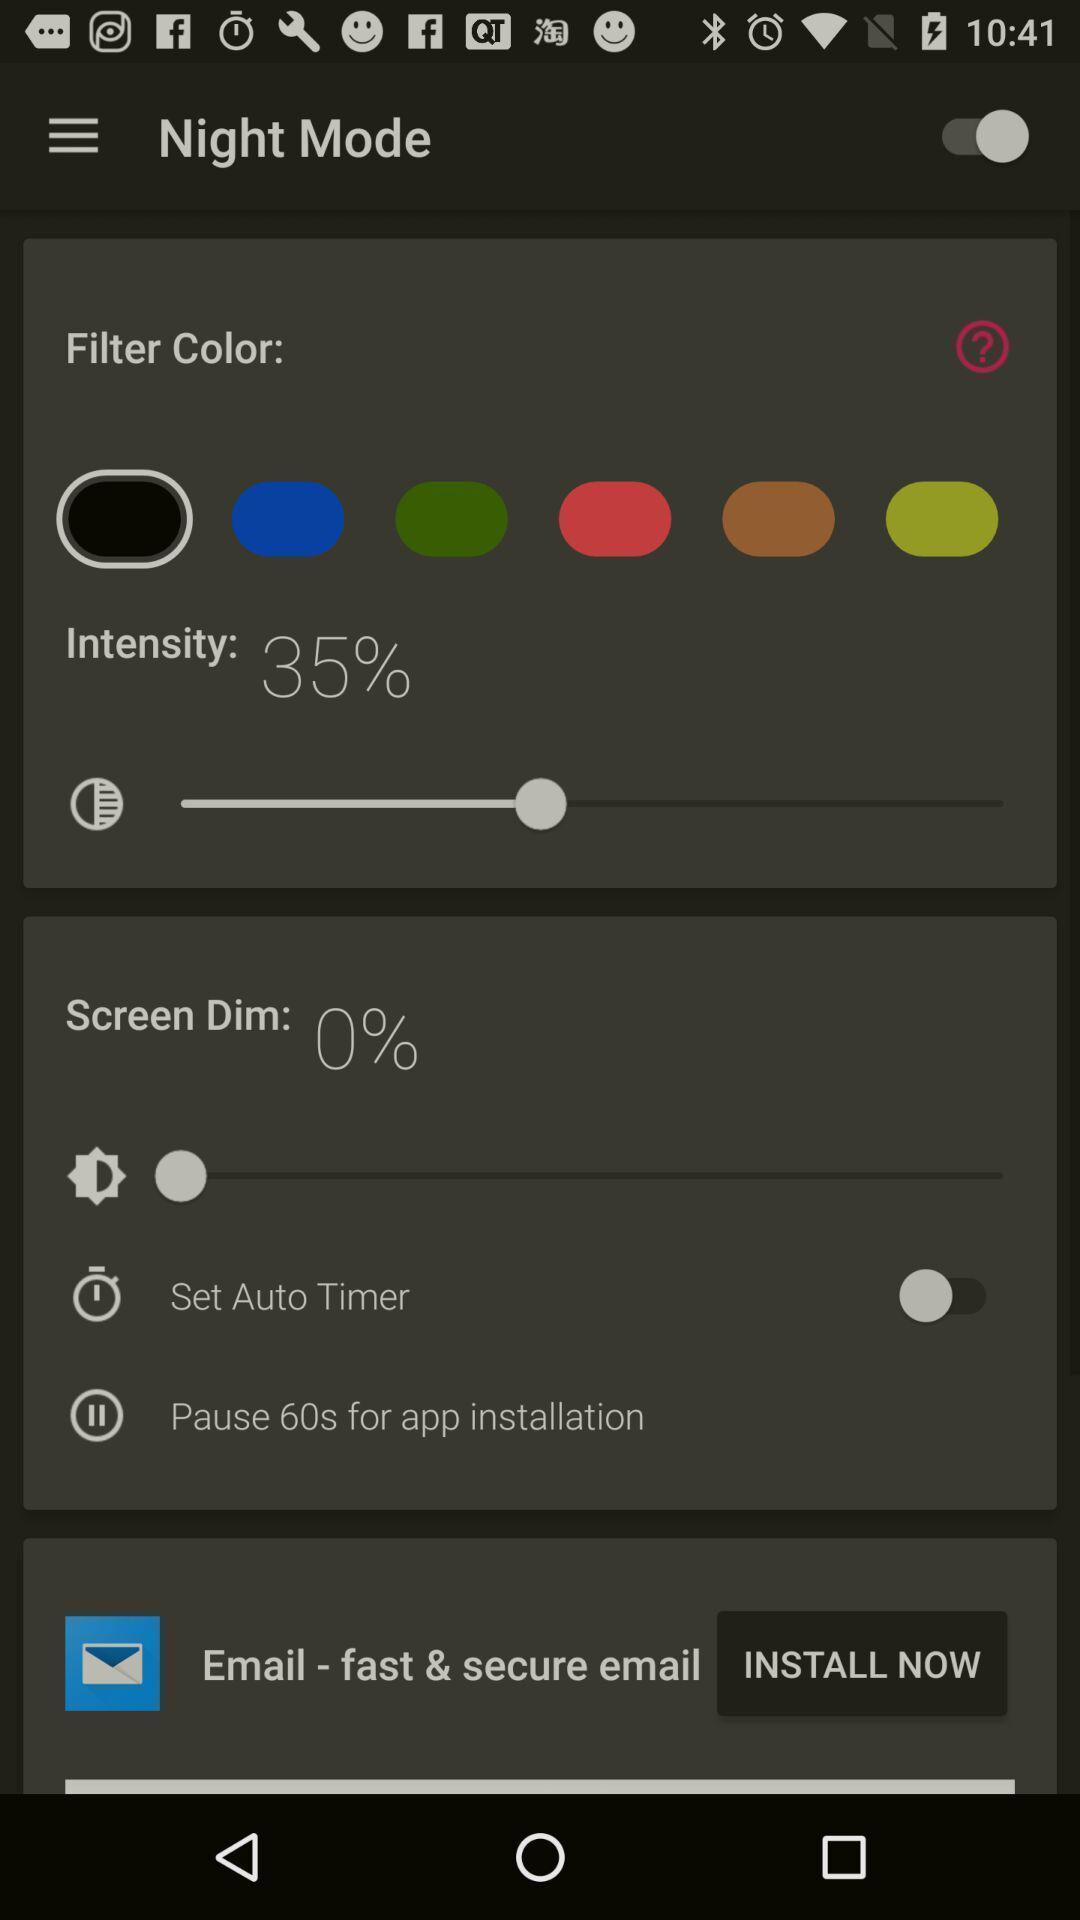What is the overall content of this screenshot? Screen shows night mode options. 